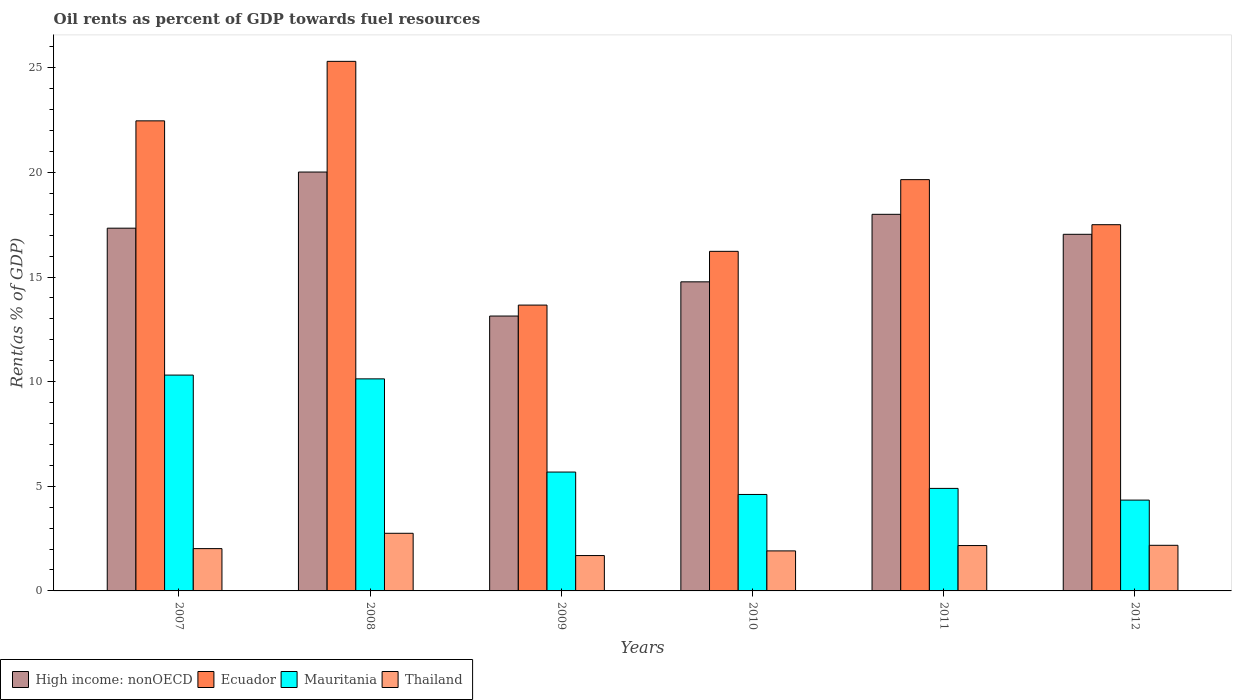Are the number of bars per tick equal to the number of legend labels?
Your answer should be compact. Yes. Are the number of bars on each tick of the X-axis equal?
Keep it short and to the point. Yes. In how many cases, is the number of bars for a given year not equal to the number of legend labels?
Make the answer very short. 0. What is the oil rent in Thailand in 2008?
Your response must be concise. 2.75. Across all years, what is the maximum oil rent in Ecuador?
Offer a terse response. 25.31. Across all years, what is the minimum oil rent in Mauritania?
Ensure brevity in your answer.  4.34. In which year was the oil rent in Thailand maximum?
Your answer should be very brief. 2008. What is the total oil rent in Mauritania in the graph?
Give a very brief answer. 39.98. What is the difference between the oil rent in Mauritania in 2010 and that in 2012?
Keep it short and to the point. 0.27. What is the difference between the oil rent in High income: nonOECD in 2011 and the oil rent in Mauritania in 2007?
Ensure brevity in your answer.  7.68. What is the average oil rent in Ecuador per year?
Provide a succinct answer. 19.14. In the year 2007, what is the difference between the oil rent in Mauritania and oil rent in Thailand?
Offer a very short reply. 8.29. In how many years, is the oil rent in Ecuador greater than 9 %?
Offer a very short reply. 6. What is the ratio of the oil rent in Ecuador in 2008 to that in 2009?
Make the answer very short. 1.85. What is the difference between the highest and the second highest oil rent in Ecuador?
Ensure brevity in your answer.  2.84. What is the difference between the highest and the lowest oil rent in Thailand?
Offer a very short reply. 1.06. In how many years, is the oil rent in Thailand greater than the average oil rent in Thailand taken over all years?
Provide a short and direct response. 3. Is it the case that in every year, the sum of the oil rent in Mauritania and oil rent in Ecuador is greater than the sum of oil rent in Thailand and oil rent in High income: nonOECD?
Keep it short and to the point. Yes. What does the 2nd bar from the left in 2007 represents?
Make the answer very short. Ecuador. What does the 1st bar from the right in 2007 represents?
Provide a succinct answer. Thailand. Is it the case that in every year, the sum of the oil rent in Thailand and oil rent in High income: nonOECD is greater than the oil rent in Mauritania?
Keep it short and to the point. Yes. What is the difference between two consecutive major ticks on the Y-axis?
Make the answer very short. 5. Are the values on the major ticks of Y-axis written in scientific E-notation?
Make the answer very short. No. Does the graph contain any zero values?
Offer a terse response. No. Does the graph contain grids?
Your answer should be very brief. No. Where does the legend appear in the graph?
Ensure brevity in your answer.  Bottom left. What is the title of the graph?
Give a very brief answer. Oil rents as percent of GDP towards fuel resources. What is the label or title of the Y-axis?
Offer a very short reply. Rent(as % of GDP). What is the Rent(as % of GDP) of High income: nonOECD in 2007?
Ensure brevity in your answer.  17.34. What is the Rent(as % of GDP) in Ecuador in 2007?
Make the answer very short. 22.47. What is the Rent(as % of GDP) in Mauritania in 2007?
Give a very brief answer. 10.32. What is the Rent(as % of GDP) in Thailand in 2007?
Keep it short and to the point. 2.02. What is the Rent(as % of GDP) in High income: nonOECD in 2008?
Offer a terse response. 20.02. What is the Rent(as % of GDP) in Ecuador in 2008?
Keep it short and to the point. 25.31. What is the Rent(as % of GDP) of Mauritania in 2008?
Your response must be concise. 10.13. What is the Rent(as % of GDP) in Thailand in 2008?
Your answer should be compact. 2.75. What is the Rent(as % of GDP) in High income: nonOECD in 2009?
Give a very brief answer. 13.14. What is the Rent(as % of GDP) of Ecuador in 2009?
Offer a very short reply. 13.66. What is the Rent(as % of GDP) in Mauritania in 2009?
Provide a short and direct response. 5.68. What is the Rent(as % of GDP) of Thailand in 2009?
Your answer should be very brief. 1.69. What is the Rent(as % of GDP) of High income: nonOECD in 2010?
Make the answer very short. 14.77. What is the Rent(as % of GDP) in Ecuador in 2010?
Your response must be concise. 16.23. What is the Rent(as % of GDP) in Mauritania in 2010?
Give a very brief answer. 4.61. What is the Rent(as % of GDP) of Thailand in 2010?
Provide a short and direct response. 1.91. What is the Rent(as % of GDP) of High income: nonOECD in 2011?
Offer a terse response. 18. What is the Rent(as % of GDP) in Ecuador in 2011?
Your response must be concise. 19.66. What is the Rent(as % of GDP) of Mauritania in 2011?
Provide a succinct answer. 4.9. What is the Rent(as % of GDP) of Thailand in 2011?
Your answer should be compact. 2.17. What is the Rent(as % of GDP) in High income: nonOECD in 2012?
Give a very brief answer. 17.04. What is the Rent(as % of GDP) of Ecuador in 2012?
Offer a very short reply. 17.5. What is the Rent(as % of GDP) of Mauritania in 2012?
Ensure brevity in your answer.  4.34. What is the Rent(as % of GDP) in Thailand in 2012?
Provide a succinct answer. 2.18. Across all years, what is the maximum Rent(as % of GDP) of High income: nonOECD?
Your response must be concise. 20.02. Across all years, what is the maximum Rent(as % of GDP) in Ecuador?
Provide a succinct answer. 25.31. Across all years, what is the maximum Rent(as % of GDP) in Mauritania?
Give a very brief answer. 10.32. Across all years, what is the maximum Rent(as % of GDP) of Thailand?
Keep it short and to the point. 2.75. Across all years, what is the minimum Rent(as % of GDP) of High income: nonOECD?
Provide a succinct answer. 13.14. Across all years, what is the minimum Rent(as % of GDP) in Ecuador?
Give a very brief answer. 13.66. Across all years, what is the minimum Rent(as % of GDP) in Mauritania?
Give a very brief answer. 4.34. Across all years, what is the minimum Rent(as % of GDP) in Thailand?
Your response must be concise. 1.69. What is the total Rent(as % of GDP) in High income: nonOECD in the graph?
Ensure brevity in your answer.  100.31. What is the total Rent(as % of GDP) of Ecuador in the graph?
Offer a very short reply. 114.83. What is the total Rent(as % of GDP) of Mauritania in the graph?
Offer a very short reply. 39.98. What is the total Rent(as % of GDP) in Thailand in the graph?
Give a very brief answer. 12.73. What is the difference between the Rent(as % of GDP) of High income: nonOECD in 2007 and that in 2008?
Provide a succinct answer. -2.68. What is the difference between the Rent(as % of GDP) in Ecuador in 2007 and that in 2008?
Provide a short and direct response. -2.84. What is the difference between the Rent(as % of GDP) of Mauritania in 2007 and that in 2008?
Provide a succinct answer. 0.18. What is the difference between the Rent(as % of GDP) in Thailand in 2007 and that in 2008?
Your response must be concise. -0.73. What is the difference between the Rent(as % of GDP) in High income: nonOECD in 2007 and that in 2009?
Give a very brief answer. 4.2. What is the difference between the Rent(as % of GDP) in Ecuador in 2007 and that in 2009?
Provide a short and direct response. 8.81. What is the difference between the Rent(as % of GDP) of Mauritania in 2007 and that in 2009?
Give a very brief answer. 4.63. What is the difference between the Rent(as % of GDP) in Thailand in 2007 and that in 2009?
Offer a very short reply. 0.33. What is the difference between the Rent(as % of GDP) in High income: nonOECD in 2007 and that in 2010?
Your answer should be very brief. 2.56. What is the difference between the Rent(as % of GDP) of Ecuador in 2007 and that in 2010?
Offer a terse response. 6.24. What is the difference between the Rent(as % of GDP) in Mauritania in 2007 and that in 2010?
Make the answer very short. 5.7. What is the difference between the Rent(as % of GDP) of Thailand in 2007 and that in 2010?
Offer a very short reply. 0.11. What is the difference between the Rent(as % of GDP) in High income: nonOECD in 2007 and that in 2011?
Your answer should be compact. -0.66. What is the difference between the Rent(as % of GDP) in Ecuador in 2007 and that in 2011?
Keep it short and to the point. 2.81. What is the difference between the Rent(as % of GDP) of Mauritania in 2007 and that in 2011?
Offer a terse response. 5.42. What is the difference between the Rent(as % of GDP) in Thailand in 2007 and that in 2011?
Provide a short and direct response. -0.15. What is the difference between the Rent(as % of GDP) in High income: nonOECD in 2007 and that in 2012?
Provide a short and direct response. 0.29. What is the difference between the Rent(as % of GDP) in Ecuador in 2007 and that in 2012?
Provide a succinct answer. 4.96. What is the difference between the Rent(as % of GDP) of Mauritania in 2007 and that in 2012?
Your answer should be compact. 5.97. What is the difference between the Rent(as % of GDP) of Thailand in 2007 and that in 2012?
Your response must be concise. -0.16. What is the difference between the Rent(as % of GDP) in High income: nonOECD in 2008 and that in 2009?
Make the answer very short. 6.88. What is the difference between the Rent(as % of GDP) of Ecuador in 2008 and that in 2009?
Offer a very short reply. 11.65. What is the difference between the Rent(as % of GDP) in Mauritania in 2008 and that in 2009?
Make the answer very short. 4.45. What is the difference between the Rent(as % of GDP) in Thailand in 2008 and that in 2009?
Provide a short and direct response. 1.06. What is the difference between the Rent(as % of GDP) of High income: nonOECD in 2008 and that in 2010?
Keep it short and to the point. 5.25. What is the difference between the Rent(as % of GDP) in Ecuador in 2008 and that in 2010?
Give a very brief answer. 9.08. What is the difference between the Rent(as % of GDP) of Mauritania in 2008 and that in 2010?
Your response must be concise. 5.52. What is the difference between the Rent(as % of GDP) in Thailand in 2008 and that in 2010?
Provide a short and direct response. 0.84. What is the difference between the Rent(as % of GDP) in High income: nonOECD in 2008 and that in 2011?
Keep it short and to the point. 2.02. What is the difference between the Rent(as % of GDP) of Ecuador in 2008 and that in 2011?
Keep it short and to the point. 5.65. What is the difference between the Rent(as % of GDP) in Mauritania in 2008 and that in 2011?
Your answer should be very brief. 5.23. What is the difference between the Rent(as % of GDP) in Thailand in 2008 and that in 2011?
Provide a short and direct response. 0.59. What is the difference between the Rent(as % of GDP) in High income: nonOECD in 2008 and that in 2012?
Make the answer very short. 2.98. What is the difference between the Rent(as % of GDP) in Ecuador in 2008 and that in 2012?
Provide a short and direct response. 7.81. What is the difference between the Rent(as % of GDP) of Mauritania in 2008 and that in 2012?
Your answer should be very brief. 5.79. What is the difference between the Rent(as % of GDP) of Thailand in 2008 and that in 2012?
Provide a succinct answer. 0.57. What is the difference between the Rent(as % of GDP) of High income: nonOECD in 2009 and that in 2010?
Provide a succinct answer. -1.63. What is the difference between the Rent(as % of GDP) in Ecuador in 2009 and that in 2010?
Provide a succinct answer. -2.57. What is the difference between the Rent(as % of GDP) in Mauritania in 2009 and that in 2010?
Offer a terse response. 1.07. What is the difference between the Rent(as % of GDP) in Thailand in 2009 and that in 2010?
Keep it short and to the point. -0.22. What is the difference between the Rent(as % of GDP) in High income: nonOECD in 2009 and that in 2011?
Give a very brief answer. -4.86. What is the difference between the Rent(as % of GDP) of Ecuador in 2009 and that in 2011?
Make the answer very short. -6. What is the difference between the Rent(as % of GDP) in Mauritania in 2009 and that in 2011?
Offer a very short reply. 0.78. What is the difference between the Rent(as % of GDP) in Thailand in 2009 and that in 2011?
Offer a very short reply. -0.48. What is the difference between the Rent(as % of GDP) of High income: nonOECD in 2009 and that in 2012?
Make the answer very short. -3.91. What is the difference between the Rent(as % of GDP) of Ecuador in 2009 and that in 2012?
Your answer should be compact. -3.84. What is the difference between the Rent(as % of GDP) of Mauritania in 2009 and that in 2012?
Keep it short and to the point. 1.34. What is the difference between the Rent(as % of GDP) of Thailand in 2009 and that in 2012?
Offer a very short reply. -0.49. What is the difference between the Rent(as % of GDP) in High income: nonOECD in 2010 and that in 2011?
Your response must be concise. -3.23. What is the difference between the Rent(as % of GDP) of Ecuador in 2010 and that in 2011?
Give a very brief answer. -3.43. What is the difference between the Rent(as % of GDP) of Mauritania in 2010 and that in 2011?
Offer a terse response. -0.29. What is the difference between the Rent(as % of GDP) of Thailand in 2010 and that in 2011?
Offer a very short reply. -0.26. What is the difference between the Rent(as % of GDP) in High income: nonOECD in 2010 and that in 2012?
Give a very brief answer. -2.27. What is the difference between the Rent(as % of GDP) of Ecuador in 2010 and that in 2012?
Give a very brief answer. -1.27. What is the difference between the Rent(as % of GDP) in Mauritania in 2010 and that in 2012?
Your answer should be very brief. 0.27. What is the difference between the Rent(as % of GDP) in Thailand in 2010 and that in 2012?
Offer a terse response. -0.27. What is the difference between the Rent(as % of GDP) in High income: nonOECD in 2011 and that in 2012?
Provide a short and direct response. 0.95. What is the difference between the Rent(as % of GDP) in Ecuador in 2011 and that in 2012?
Offer a very short reply. 2.15. What is the difference between the Rent(as % of GDP) of Mauritania in 2011 and that in 2012?
Your answer should be compact. 0.56. What is the difference between the Rent(as % of GDP) in Thailand in 2011 and that in 2012?
Ensure brevity in your answer.  -0.01. What is the difference between the Rent(as % of GDP) in High income: nonOECD in 2007 and the Rent(as % of GDP) in Ecuador in 2008?
Provide a succinct answer. -7.97. What is the difference between the Rent(as % of GDP) in High income: nonOECD in 2007 and the Rent(as % of GDP) in Mauritania in 2008?
Give a very brief answer. 7.2. What is the difference between the Rent(as % of GDP) in High income: nonOECD in 2007 and the Rent(as % of GDP) in Thailand in 2008?
Offer a very short reply. 14.58. What is the difference between the Rent(as % of GDP) in Ecuador in 2007 and the Rent(as % of GDP) in Mauritania in 2008?
Your answer should be very brief. 12.33. What is the difference between the Rent(as % of GDP) of Ecuador in 2007 and the Rent(as % of GDP) of Thailand in 2008?
Make the answer very short. 19.71. What is the difference between the Rent(as % of GDP) of Mauritania in 2007 and the Rent(as % of GDP) of Thailand in 2008?
Your answer should be very brief. 7.56. What is the difference between the Rent(as % of GDP) in High income: nonOECD in 2007 and the Rent(as % of GDP) in Ecuador in 2009?
Offer a very short reply. 3.68. What is the difference between the Rent(as % of GDP) of High income: nonOECD in 2007 and the Rent(as % of GDP) of Mauritania in 2009?
Your response must be concise. 11.66. What is the difference between the Rent(as % of GDP) of High income: nonOECD in 2007 and the Rent(as % of GDP) of Thailand in 2009?
Provide a short and direct response. 15.65. What is the difference between the Rent(as % of GDP) in Ecuador in 2007 and the Rent(as % of GDP) in Mauritania in 2009?
Your answer should be compact. 16.79. What is the difference between the Rent(as % of GDP) in Ecuador in 2007 and the Rent(as % of GDP) in Thailand in 2009?
Your answer should be very brief. 20.78. What is the difference between the Rent(as % of GDP) of Mauritania in 2007 and the Rent(as % of GDP) of Thailand in 2009?
Give a very brief answer. 8.62. What is the difference between the Rent(as % of GDP) in High income: nonOECD in 2007 and the Rent(as % of GDP) in Ecuador in 2010?
Give a very brief answer. 1.11. What is the difference between the Rent(as % of GDP) of High income: nonOECD in 2007 and the Rent(as % of GDP) of Mauritania in 2010?
Your response must be concise. 12.73. What is the difference between the Rent(as % of GDP) of High income: nonOECD in 2007 and the Rent(as % of GDP) of Thailand in 2010?
Provide a succinct answer. 15.42. What is the difference between the Rent(as % of GDP) in Ecuador in 2007 and the Rent(as % of GDP) in Mauritania in 2010?
Provide a short and direct response. 17.86. What is the difference between the Rent(as % of GDP) in Ecuador in 2007 and the Rent(as % of GDP) in Thailand in 2010?
Your response must be concise. 20.55. What is the difference between the Rent(as % of GDP) in Mauritania in 2007 and the Rent(as % of GDP) in Thailand in 2010?
Ensure brevity in your answer.  8.4. What is the difference between the Rent(as % of GDP) of High income: nonOECD in 2007 and the Rent(as % of GDP) of Ecuador in 2011?
Your answer should be very brief. -2.32. What is the difference between the Rent(as % of GDP) of High income: nonOECD in 2007 and the Rent(as % of GDP) of Mauritania in 2011?
Keep it short and to the point. 12.44. What is the difference between the Rent(as % of GDP) in High income: nonOECD in 2007 and the Rent(as % of GDP) in Thailand in 2011?
Provide a short and direct response. 15.17. What is the difference between the Rent(as % of GDP) of Ecuador in 2007 and the Rent(as % of GDP) of Mauritania in 2011?
Your response must be concise. 17.57. What is the difference between the Rent(as % of GDP) of Ecuador in 2007 and the Rent(as % of GDP) of Thailand in 2011?
Provide a short and direct response. 20.3. What is the difference between the Rent(as % of GDP) in Mauritania in 2007 and the Rent(as % of GDP) in Thailand in 2011?
Keep it short and to the point. 8.15. What is the difference between the Rent(as % of GDP) of High income: nonOECD in 2007 and the Rent(as % of GDP) of Ecuador in 2012?
Offer a terse response. -0.17. What is the difference between the Rent(as % of GDP) of High income: nonOECD in 2007 and the Rent(as % of GDP) of Mauritania in 2012?
Keep it short and to the point. 13. What is the difference between the Rent(as % of GDP) in High income: nonOECD in 2007 and the Rent(as % of GDP) in Thailand in 2012?
Your answer should be very brief. 15.16. What is the difference between the Rent(as % of GDP) in Ecuador in 2007 and the Rent(as % of GDP) in Mauritania in 2012?
Provide a succinct answer. 18.13. What is the difference between the Rent(as % of GDP) in Ecuador in 2007 and the Rent(as % of GDP) in Thailand in 2012?
Provide a short and direct response. 20.29. What is the difference between the Rent(as % of GDP) of Mauritania in 2007 and the Rent(as % of GDP) of Thailand in 2012?
Ensure brevity in your answer.  8.14. What is the difference between the Rent(as % of GDP) of High income: nonOECD in 2008 and the Rent(as % of GDP) of Ecuador in 2009?
Offer a terse response. 6.36. What is the difference between the Rent(as % of GDP) of High income: nonOECD in 2008 and the Rent(as % of GDP) of Mauritania in 2009?
Give a very brief answer. 14.34. What is the difference between the Rent(as % of GDP) of High income: nonOECD in 2008 and the Rent(as % of GDP) of Thailand in 2009?
Give a very brief answer. 18.33. What is the difference between the Rent(as % of GDP) in Ecuador in 2008 and the Rent(as % of GDP) in Mauritania in 2009?
Your response must be concise. 19.63. What is the difference between the Rent(as % of GDP) of Ecuador in 2008 and the Rent(as % of GDP) of Thailand in 2009?
Keep it short and to the point. 23.62. What is the difference between the Rent(as % of GDP) of Mauritania in 2008 and the Rent(as % of GDP) of Thailand in 2009?
Offer a very short reply. 8.44. What is the difference between the Rent(as % of GDP) in High income: nonOECD in 2008 and the Rent(as % of GDP) in Ecuador in 2010?
Your answer should be compact. 3.79. What is the difference between the Rent(as % of GDP) of High income: nonOECD in 2008 and the Rent(as % of GDP) of Mauritania in 2010?
Keep it short and to the point. 15.41. What is the difference between the Rent(as % of GDP) of High income: nonOECD in 2008 and the Rent(as % of GDP) of Thailand in 2010?
Your response must be concise. 18.11. What is the difference between the Rent(as % of GDP) of Ecuador in 2008 and the Rent(as % of GDP) of Mauritania in 2010?
Ensure brevity in your answer.  20.7. What is the difference between the Rent(as % of GDP) of Ecuador in 2008 and the Rent(as % of GDP) of Thailand in 2010?
Provide a succinct answer. 23.4. What is the difference between the Rent(as % of GDP) of Mauritania in 2008 and the Rent(as % of GDP) of Thailand in 2010?
Provide a short and direct response. 8.22. What is the difference between the Rent(as % of GDP) in High income: nonOECD in 2008 and the Rent(as % of GDP) in Ecuador in 2011?
Offer a terse response. 0.36. What is the difference between the Rent(as % of GDP) in High income: nonOECD in 2008 and the Rent(as % of GDP) in Mauritania in 2011?
Your answer should be compact. 15.12. What is the difference between the Rent(as % of GDP) of High income: nonOECD in 2008 and the Rent(as % of GDP) of Thailand in 2011?
Offer a terse response. 17.85. What is the difference between the Rent(as % of GDP) in Ecuador in 2008 and the Rent(as % of GDP) in Mauritania in 2011?
Your answer should be compact. 20.41. What is the difference between the Rent(as % of GDP) in Ecuador in 2008 and the Rent(as % of GDP) in Thailand in 2011?
Provide a succinct answer. 23.14. What is the difference between the Rent(as % of GDP) of Mauritania in 2008 and the Rent(as % of GDP) of Thailand in 2011?
Offer a very short reply. 7.97. What is the difference between the Rent(as % of GDP) of High income: nonOECD in 2008 and the Rent(as % of GDP) of Ecuador in 2012?
Your answer should be compact. 2.52. What is the difference between the Rent(as % of GDP) of High income: nonOECD in 2008 and the Rent(as % of GDP) of Mauritania in 2012?
Keep it short and to the point. 15.68. What is the difference between the Rent(as % of GDP) of High income: nonOECD in 2008 and the Rent(as % of GDP) of Thailand in 2012?
Provide a short and direct response. 17.84. What is the difference between the Rent(as % of GDP) in Ecuador in 2008 and the Rent(as % of GDP) in Mauritania in 2012?
Your answer should be compact. 20.97. What is the difference between the Rent(as % of GDP) of Ecuador in 2008 and the Rent(as % of GDP) of Thailand in 2012?
Offer a very short reply. 23.13. What is the difference between the Rent(as % of GDP) in Mauritania in 2008 and the Rent(as % of GDP) in Thailand in 2012?
Your answer should be very brief. 7.95. What is the difference between the Rent(as % of GDP) in High income: nonOECD in 2009 and the Rent(as % of GDP) in Ecuador in 2010?
Provide a short and direct response. -3.09. What is the difference between the Rent(as % of GDP) in High income: nonOECD in 2009 and the Rent(as % of GDP) in Mauritania in 2010?
Provide a short and direct response. 8.53. What is the difference between the Rent(as % of GDP) of High income: nonOECD in 2009 and the Rent(as % of GDP) of Thailand in 2010?
Give a very brief answer. 11.23. What is the difference between the Rent(as % of GDP) in Ecuador in 2009 and the Rent(as % of GDP) in Mauritania in 2010?
Your answer should be compact. 9.05. What is the difference between the Rent(as % of GDP) of Ecuador in 2009 and the Rent(as % of GDP) of Thailand in 2010?
Give a very brief answer. 11.75. What is the difference between the Rent(as % of GDP) in Mauritania in 2009 and the Rent(as % of GDP) in Thailand in 2010?
Keep it short and to the point. 3.77. What is the difference between the Rent(as % of GDP) of High income: nonOECD in 2009 and the Rent(as % of GDP) of Ecuador in 2011?
Make the answer very short. -6.52. What is the difference between the Rent(as % of GDP) of High income: nonOECD in 2009 and the Rent(as % of GDP) of Mauritania in 2011?
Give a very brief answer. 8.24. What is the difference between the Rent(as % of GDP) of High income: nonOECD in 2009 and the Rent(as % of GDP) of Thailand in 2011?
Offer a very short reply. 10.97. What is the difference between the Rent(as % of GDP) in Ecuador in 2009 and the Rent(as % of GDP) in Mauritania in 2011?
Provide a short and direct response. 8.76. What is the difference between the Rent(as % of GDP) in Ecuador in 2009 and the Rent(as % of GDP) in Thailand in 2011?
Your response must be concise. 11.49. What is the difference between the Rent(as % of GDP) in Mauritania in 2009 and the Rent(as % of GDP) in Thailand in 2011?
Your response must be concise. 3.51. What is the difference between the Rent(as % of GDP) in High income: nonOECD in 2009 and the Rent(as % of GDP) in Ecuador in 2012?
Provide a succinct answer. -4.37. What is the difference between the Rent(as % of GDP) in High income: nonOECD in 2009 and the Rent(as % of GDP) in Mauritania in 2012?
Provide a succinct answer. 8.8. What is the difference between the Rent(as % of GDP) of High income: nonOECD in 2009 and the Rent(as % of GDP) of Thailand in 2012?
Your response must be concise. 10.96. What is the difference between the Rent(as % of GDP) in Ecuador in 2009 and the Rent(as % of GDP) in Mauritania in 2012?
Offer a terse response. 9.32. What is the difference between the Rent(as % of GDP) in Ecuador in 2009 and the Rent(as % of GDP) in Thailand in 2012?
Ensure brevity in your answer.  11.48. What is the difference between the Rent(as % of GDP) in Mauritania in 2009 and the Rent(as % of GDP) in Thailand in 2012?
Keep it short and to the point. 3.5. What is the difference between the Rent(as % of GDP) in High income: nonOECD in 2010 and the Rent(as % of GDP) in Ecuador in 2011?
Make the answer very short. -4.88. What is the difference between the Rent(as % of GDP) in High income: nonOECD in 2010 and the Rent(as % of GDP) in Mauritania in 2011?
Offer a very short reply. 9.87. What is the difference between the Rent(as % of GDP) in High income: nonOECD in 2010 and the Rent(as % of GDP) in Thailand in 2011?
Provide a succinct answer. 12.6. What is the difference between the Rent(as % of GDP) of Ecuador in 2010 and the Rent(as % of GDP) of Mauritania in 2011?
Offer a terse response. 11.33. What is the difference between the Rent(as % of GDP) in Ecuador in 2010 and the Rent(as % of GDP) in Thailand in 2011?
Give a very brief answer. 14.06. What is the difference between the Rent(as % of GDP) of Mauritania in 2010 and the Rent(as % of GDP) of Thailand in 2011?
Offer a very short reply. 2.44. What is the difference between the Rent(as % of GDP) of High income: nonOECD in 2010 and the Rent(as % of GDP) of Ecuador in 2012?
Make the answer very short. -2.73. What is the difference between the Rent(as % of GDP) of High income: nonOECD in 2010 and the Rent(as % of GDP) of Mauritania in 2012?
Your answer should be compact. 10.43. What is the difference between the Rent(as % of GDP) in High income: nonOECD in 2010 and the Rent(as % of GDP) in Thailand in 2012?
Your response must be concise. 12.59. What is the difference between the Rent(as % of GDP) of Ecuador in 2010 and the Rent(as % of GDP) of Mauritania in 2012?
Provide a succinct answer. 11.89. What is the difference between the Rent(as % of GDP) in Ecuador in 2010 and the Rent(as % of GDP) in Thailand in 2012?
Ensure brevity in your answer.  14.05. What is the difference between the Rent(as % of GDP) of Mauritania in 2010 and the Rent(as % of GDP) of Thailand in 2012?
Your answer should be compact. 2.43. What is the difference between the Rent(as % of GDP) in High income: nonOECD in 2011 and the Rent(as % of GDP) in Ecuador in 2012?
Give a very brief answer. 0.5. What is the difference between the Rent(as % of GDP) of High income: nonOECD in 2011 and the Rent(as % of GDP) of Mauritania in 2012?
Provide a short and direct response. 13.66. What is the difference between the Rent(as % of GDP) of High income: nonOECD in 2011 and the Rent(as % of GDP) of Thailand in 2012?
Ensure brevity in your answer.  15.82. What is the difference between the Rent(as % of GDP) in Ecuador in 2011 and the Rent(as % of GDP) in Mauritania in 2012?
Your answer should be very brief. 15.32. What is the difference between the Rent(as % of GDP) in Ecuador in 2011 and the Rent(as % of GDP) in Thailand in 2012?
Make the answer very short. 17.48. What is the difference between the Rent(as % of GDP) of Mauritania in 2011 and the Rent(as % of GDP) of Thailand in 2012?
Make the answer very short. 2.72. What is the average Rent(as % of GDP) of High income: nonOECD per year?
Provide a succinct answer. 16.72. What is the average Rent(as % of GDP) of Ecuador per year?
Your response must be concise. 19.14. What is the average Rent(as % of GDP) in Mauritania per year?
Your response must be concise. 6.66. What is the average Rent(as % of GDP) in Thailand per year?
Make the answer very short. 2.12. In the year 2007, what is the difference between the Rent(as % of GDP) in High income: nonOECD and Rent(as % of GDP) in Ecuador?
Provide a short and direct response. -5.13. In the year 2007, what is the difference between the Rent(as % of GDP) in High income: nonOECD and Rent(as % of GDP) in Mauritania?
Offer a very short reply. 7.02. In the year 2007, what is the difference between the Rent(as % of GDP) of High income: nonOECD and Rent(as % of GDP) of Thailand?
Ensure brevity in your answer.  15.31. In the year 2007, what is the difference between the Rent(as % of GDP) of Ecuador and Rent(as % of GDP) of Mauritania?
Your answer should be compact. 12.15. In the year 2007, what is the difference between the Rent(as % of GDP) in Ecuador and Rent(as % of GDP) in Thailand?
Your answer should be compact. 20.44. In the year 2007, what is the difference between the Rent(as % of GDP) of Mauritania and Rent(as % of GDP) of Thailand?
Your answer should be compact. 8.29. In the year 2008, what is the difference between the Rent(as % of GDP) in High income: nonOECD and Rent(as % of GDP) in Ecuador?
Offer a very short reply. -5.29. In the year 2008, what is the difference between the Rent(as % of GDP) in High income: nonOECD and Rent(as % of GDP) in Mauritania?
Provide a short and direct response. 9.89. In the year 2008, what is the difference between the Rent(as % of GDP) in High income: nonOECD and Rent(as % of GDP) in Thailand?
Keep it short and to the point. 17.27. In the year 2008, what is the difference between the Rent(as % of GDP) in Ecuador and Rent(as % of GDP) in Mauritania?
Offer a very short reply. 15.18. In the year 2008, what is the difference between the Rent(as % of GDP) in Ecuador and Rent(as % of GDP) in Thailand?
Keep it short and to the point. 22.56. In the year 2008, what is the difference between the Rent(as % of GDP) of Mauritania and Rent(as % of GDP) of Thailand?
Make the answer very short. 7.38. In the year 2009, what is the difference between the Rent(as % of GDP) of High income: nonOECD and Rent(as % of GDP) of Ecuador?
Your response must be concise. -0.52. In the year 2009, what is the difference between the Rent(as % of GDP) of High income: nonOECD and Rent(as % of GDP) of Mauritania?
Offer a very short reply. 7.46. In the year 2009, what is the difference between the Rent(as % of GDP) in High income: nonOECD and Rent(as % of GDP) in Thailand?
Offer a terse response. 11.45. In the year 2009, what is the difference between the Rent(as % of GDP) of Ecuador and Rent(as % of GDP) of Mauritania?
Keep it short and to the point. 7.98. In the year 2009, what is the difference between the Rent(as % of GDP) of Ecuador and Rent(as % of GDP) of Thailand?
Provide a short and direct response. 11.97. In the year 2009, what is the difference between the Rent(as % of GDP) of Mauritania and Rent(as % of GDP) of Thailand?
Offer a terse response. 3.99. In the year 2010, what is the difference between the Rent(as % of GDP) of High income: nonOECD and Rent(as % of GDP) of Ecuador?
Your answer should be very brief. -1.46. In the year 2010, what is the difference between the Rent(as % of GDP) in High income: nonOECD and Rent(as % of GDP) in Mauritania?
Your answer should be compact. 10.16. In the year 2010, what is the difference between the Rent(as % of GDP) in High income: nonOECD and Rent(as % of GDP) in Thailand?
Your answer should be very brief. 12.86. In the year 2010, what is the difference between the Rent(as % of GDP) in Ecuador and Rent(as % of GDP) in Mauritania?
Your response must be concise. 11.62. In the year 2010, what is the difference between the Rent(as % of GDP) in Ecuador and Rent(as % of GDP) in Thailand?
Your response must be concise. 14.32. In the year 2010, what is the difference between the Rent(as % of GDP) of Mauritania and Rent(as % of GDP) of Thailand?
Your answer should be very brief. 2.7. In the year 2011, what is the difference between the Rent(as % of GDP) in High income: nonOECD and Rent(as % of GDP) in Ecuador?
Give a very brief answer. -1.66. In the year 2011, what is the difference between the Rent(as % of GDP) in High income: nonOECD and Rent(as % of GDP) in Mauritania?
Give a very brief answer. 13.1. In the year 2011, what is the difference between the Rent(as % of GDP) in High income: nonOECD and Rent(as % of GDP) in Thailand?
Provide a succinct answer. 15.83. In the year 2011, what is the difference between the Rent(as % of GDP) in Ecuador and Rent(as % of GDP) in Mauritania?
Your answer should be compact. 14.76. In the year 2011, what is the difference between the Rent(as % of GDP) in Ecuador and Rent(as % of GDP) in Thailand?
Your response must be concise. 17.49. In the year 2011, what is the difference between the Rent(as % of GDP) of Mauritania and Rent(as % of GDP) of Thailand?
Offer a terse response. 2.73. In the year 2012, what is the difference between the Rent(as % of GDP) in High income: nonOECD and Rent(as % of GDP) in Ecuador?
Offer a very short reply. -0.46. In the year 2012, what is the difference between the Rent(as % of GDP) of High income: nonOECD and Rent(as % of GDP) of Mauritania?
Offer a very short reply. 12.7. In the year 2012, what is the difference between the Rent(as % of GDP) in High income: nonOECD and Rent(as % of GDP) in Thailand?
Ensure brevity in your answer.  14.86. In the year 2012, what is the difference between the Rent(as % of GDP) of Ecuador and Rent(as % of GDP) of Mauritania?
Keep it short and to the point. 13.16. In the year 2012, what is the difference between the Rent(as % of GDP) in Ecuador and Rent(as % of GDP) in Thailand?
Offer a very short reply. 15.32. In the year 2012, what is the difference between the Rent(as % of GDP) in Mauritania and Rent(as % of GDP) in Thailand?
Offer a very short reply. 2.16. What is the ratio of the Rent(as % of GDP) in High income: nonOECD in 2007 to that in 2008?
Provide a succinct answer. 0.87. What is the ratio of the Rent(as % of GDP) of Ecuador in 2007 to that in 2008?
Offer a terse response. 0.89. What is the ratio of the Rent(as % of GDP) of Mauritania in 2007 to that in 2008?
Offer a very short reply. 1.02. What is the ratio of the Rent(as % of GDP) in Thailand in 2007 to that in 2008?
Your answer should be compact. 0.73. What is the ratio of the Rent(as % of GDP) in High income: nonOECD in 2007 to that in 2009?
Ensure brevity in your answer.  1.32. What is the ratio of the Rent(as % of GDP) of Ecuador in 2007 to that in 2009?
Provide a short and direct response. 1.64. What is the ratio of the Rent(as % of GDP) in Mauritania in 2007 to that in 2009?
Offer a terse response. 1.82. What is the ratio of the Rent(as % of GDP) of Thailand in 2007 to that in 2009?
Provide a short and direct response. 1.2. What is the ratio of the Rent(as % of GDP) of High income: nonOECD in 2007 to that in 2010?
Make the answer very short. 1.17. What is the ratio of the Rent(as % of GDP) of Ecuador in 2007 to that in 2010?
Offer a very short reply. 1.38. What is the ratio of the Rent(as % of GDP) in Mauritania in 2007 to that in 2010?
Make the answer very short. 2.24. What is the ratio of the Rent(as % of GDP) in Thailand in 2007 to that in 2010?
Provide a short and direct response. 1.06. What is the ratio of the Rent(as % of GDP) of High income: nonOECD in 2007 to that in 2011?
Provide a short and direct response. 0.96. What is the ratio of the Rent(as % of GDP) of Mauritania in 2007 to that in 2011?
Provide a succinct answer. 2.1. What is the ratio of the Rent(as % of GDP) of Thailand in 2007 to that in 2011?
Your answer should be very brief. 0.93. What is the ratio of the Rent(as % of GDP) of High income: nonOECD in 2007 to that in 2012?
Make the answer very short. 1.02. What is the ratio of the Rent(as % of GDP) in Ecuador in 2007 to that in 2012?
Your answer should be compact. 1.28. What is the ratio of the Rent(as % of GDP) in Mauritania in 2007 to that in 2012?
Your answer should be compact. 2.38. What is the ratio of the Rent(as % of GDP) of Thailand in 2007 to that in 2012?
Make the answer very short. 0.93. What is the ratio of the Rent(as % of GDP) of High income: nonOECD in 2008 to that in 2009?
Keep it short and to the point. 1.52. What is the ratio of the Rent(as % of GDP) in Ecuador in 2008 to that in 2009?
Offer a terse response. 1.85. What is the ratio of the Rent(as % of GDP) of Mauritania in 2008 to that in 2009?
Your answer should be very brief. 1.78. What is the ratio of the Rent(as % of GDP) in Thailand in 2008 to that in 2009?
Provide a short and direct response. 1.63. What is the ratio of the Rent(as % of GDP) in High income: nonOECD in 2008 to that in 2010?
Your answer should be very brief. 1.36. What is the ratio of the Rent(as % of GDP) in Ecuador in 2008 to that in 2010?
Provide a short and direct response. 1.56. What is the ratio of the Rent(as % of GDP) of Mauritania in 2008 to that in 2010?
Provide a succinct answer. 2.2. What is the ratio of the Rent(as % of GDP) in Thailand in 2008 to that in 2010?
Offer a very short reply. 1.44. What is the ratio of the Rent(as % of GDP) of High income: nonOECD in 2008 to that in 2011?
Give a very brief answer. 1.11. What is the ratio of the Rent(as % of GDP) of Ecuador in 2008 to that in 2011?
Offer a very short reply. 1.29. What is the ratio of the Rent(as % of GDP) in Mauritania in 2008 to that in 2011?
Your response must be concise. 2.07. What is the ratio of the Rent(as % of GDP) in Thailand in 2008 to that in 2011?
Ensure brevity in your answer.  1.27. What is the ratio of the Rent(as % of GDP) in High income: nonOECD in 2008 to that in 2012?
Make the answer very short. 1.17. What is the ratio of the Rent(as % of GDP) in Ecuador in 2008 to that in 2012?
Offer a very short reply. 1.45. What is the ratio of the Rent(as % of GDP) in Mauritania in 2008 to that in 2012?
Make the answer very short. 2.33. What is the ratio of the Rent(as % of GDP) of Thailand in 2008 to that in 2012?
Your answer should be very brief. 1.26. What is the ratio of the Rent(as % of GDP) in High income: nonOECD in 2009 to that in 2010?
Provide a succinct answer. 0.89. What is the ratio of the Rent(as % of GDP) in Ecuador in 2009 to that in 2010?
Make the answer very short. 0.84. What is the ratio of the Rent(as % of GDP) of Mauritania in 2009 to that in 2010?
Provide a short and direct response. 1.23. What is the ratio of the Rent(as % of GDP) of Thailand in 2009 to that in 2010?
Provide a short and direct response. 0.88. What is the ratio of the Rent(as % of GDP) in High income: nonOECD in 2009 to that in 2011?
Keep it short and to the point. 0.73. What is the ratio of the Rent(as % of GDP) of Ecuador in 2009 to that in 2011?
Provide a short and direct response. 0.69. What is the ratio of the Rent(as % of GDP) of Mauritania in 2009 to that in 2011?
Provide a succinct answer. 1.16. What is the ratio of the Rent(as % of GDP) of Thailand in 2009 to that in 2011?
Offer a very short reply. 0.78. What is the ratio of the Rent(as % of GDP) in High income: nonOECD in 2009 to that in 2012?
Offer a terse response. 0.77. What is the ratio of the Rent(as % of GDP) in Ecuador in 2009 to that in 2012?
Provide a succinct answer. 0.78. What is the ratio of the Rent(as % of GDP) in Mauritania in 2009 to that in 2012?
Make the answer very short. 1.31. What is the ratio of the Rent(as % of GDP) of Thailand in 2009 to that in 2012?
Ensure brevity in your answer.  0.78. What is the ratio of the Rent(as % of GDP) of High income: nonOECD in 2010 to that in 2011?
Provide a succinct answer. 0.82. What is the ratio of the Rent(as % of GDP) of Ecuador in 2010 to that in 2011?
Offer a terse response. 0.83. What is the ratio of the Rent(as % of GDP) of Mauritania in 2010 to that in 2011?
Make the answer very short. 0.94. What is the ratio of the Rent(as % of GDP) in Thailand in 2010 to that in 2011?
Offer a terse response. 0.88. What is the ratio of the Rent(as % of GDP) of High income: nonOECD in 2010 to that in 2012?
Ensure brevity in your answer.  0.87. What is the ratio of the Rent(as % of GDP) in Ecuador in 2010 to that in 2012?
Provide a succinct answer. 0.93. What is the ratio of the Rent(as % of GDP) of Mauritania in 2010 to that in 2012?
Provide a succinct answer. 1.06. What is the ratio of the Rent(as % of GDP) of Thailand in 2010 to that in 2012?
Provide a succinct answer. 0.88. What is the ratio of the Rent(as % of GDP) of High income: nonOECD in 2011 to that in 2012?
Make the answer very short. 1.06. What is the ratio of the Rent(as % of GDP) of Ecuador in 2011 to that in 2012?
Provide a short and direct response. 1.12. What is the ratio of the Rent(as % of GDP) in Mauritania in 2011 to that in 2012?
Keep it short and to the point. 1.13. What is the difference between the highest and the second highest Rent(as % of GDP) in High income: nonOECD?
Make the answer very short. 2.02. What is the difference between the highest and the second highest Rent(as % of GDP) in Ecuador?
Offer a terse response. 2.84. What is the difference between the highest and the second highest Rent(as % of GDP) of Mauritania?
Offer a terse response. 0.18. What is the difference between the highest and the second highest Rent(as % of GDP) in Thailand?
Provide a short and direct response. 0.57. What is the difference between the highest and the lowest Rent(as % of GDP) in High income: nonOECD?
Ensure brevity in your answer.  6.88. What is the difference between the highest and the lowest Rent(as % of GDP) in Ecuador?
Your answer should be compact. 11.65. What is the difference between the highest and the lowest Rent(as % of GDP) in Mauritania?
Keep it short and to the point. 5.97. What is the difference between the highest and the lowest Rent(as % of GDP) of Thailand?
Your answer should be very brief. 1.06. 